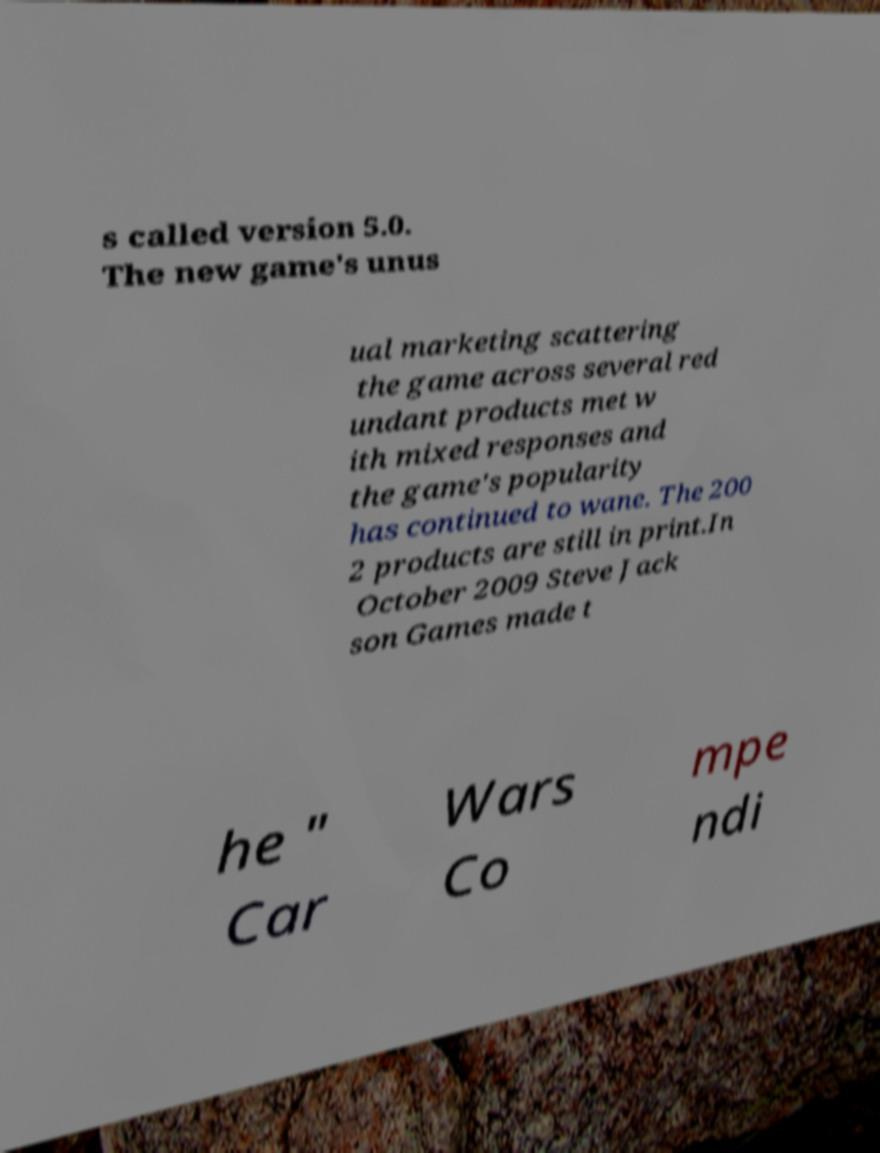Could you assist in decoding the text presented in this image and type it out clearly? s called version 5.0. The new game's unus ual marketing scattering the game across several red undant products met w ith mixed responses and the game's popularity has continued to wane. The 200 2 products are still in print.In October 2009 Steve Jack son Games made t he " Car Wars Co mpe ndi 